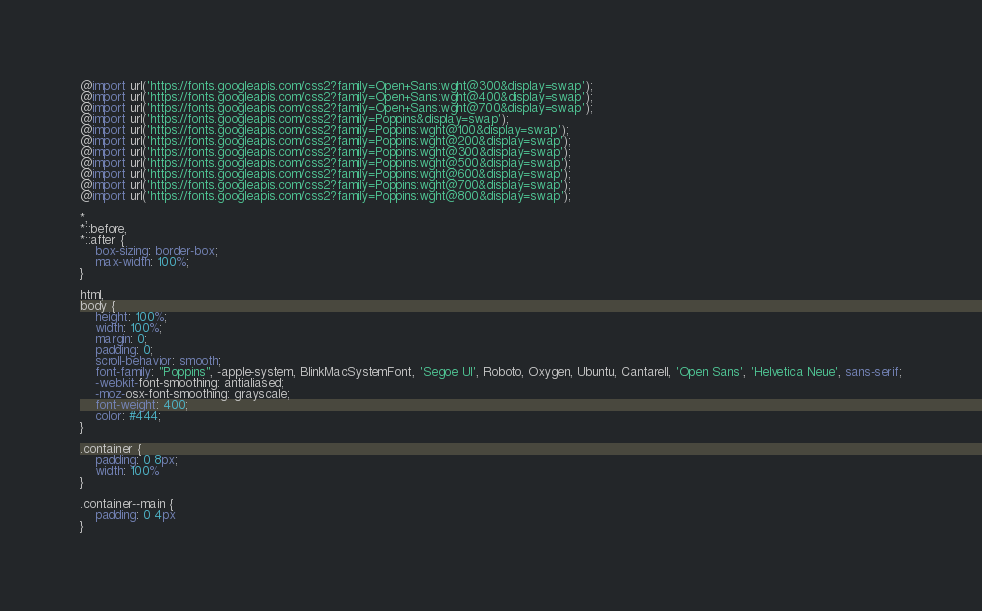<code> <loc_0><loc_0><loc_500><loc_500><_CSS_>@import url('https://fonts.googleapis.com/css2?family=Open+Sans:wght@300&display=swap');
@import url('https://fonts.googleapis.com/css2?family=Open+Sans:wght@400&display=swap');
@import url('https://fonts.googleapis.com/css2?family=Open+Sans:wght@700&display=swap');
@import url('https://fonts.googleapis.com/css2?family=Poppins&display=swap');
@import url('https://fonts.googleapis.com/css2?family=Poppins:wght@100&display=swap');
@import url('https://fonts.googleapis.com/css2?family=Poppins:wght@200&display=swap');
@import url('https://fonts.googleapis.com/css2?family=Poppins:wght@300&display=swap');
@import url('https://fonts.googleapis.com/css2?family=Poppins:wght@500&display=swap');
@import url('https://fonts.googleapis.com/css2?family=Poppins:wght@600&display=swap');
@import url('https://fonts.googleapis.com/css2?family=Poppins:wght@700&display=swap');
@import url('https://fonts.googleapis.com/css2?family=Poppins:wght@800&display=swap');

*,
*::before,
*::after {
    box-sizing: border-box;
    max-width: 100%;
}

html,
body {
    height: 100%;
    width: 100%;
    margin: 0;
    padding: 0;
    scroll-behavior: smooth;
    font-family: "Poppins", -apple-system, BlinkMacSystemFont, 'Segoe UI', Roboto, Oxygen, Ubuntu, Cantarell, 'Open Sans', 'Helvetica Neue', sans-serif;
    -webkit-font-smoothing: antialiased;
    -moz-osx-font-smoothing: grayscale;
    font-weight: 400;
    color: #444;
}

.container {
    padding: 0 8px;
    width: 100%
}

.container--main {
    padding: 0 4px
}
</code> 